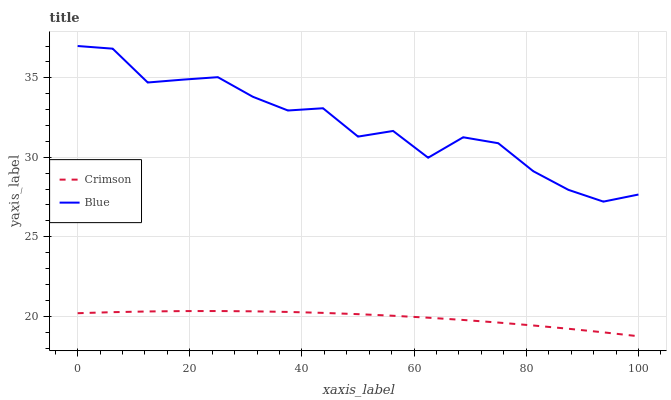Does Crimson have the minimum area under the curve?
Answer yes or no. Yes. Does Blue have the maximum area under the curve?
Answer yes or no. Yes. Does Blue have the minimum area under the curve?
Answer yes or no. No. Is Crimson the smoothest?
Answer yes or no. Yes. Is Blue the roughest?
Answer yes or no. Yes. Is Blue the smoothest?
Answer yes or no. No. Does Crimson have the lowest value?
Answer yes or no. Yes. Does Blue have the lowest value?
Answer yes or no. No. Does Blue have the highest value?
Answer yes or no. Yes. Is Crimson less than Blue?
Answer yes or no. Yes. Is Blue greater than Crimson?
Answer yes or no. Yes. Does Crimson intersect Blue?
Answer yes or no. No. 